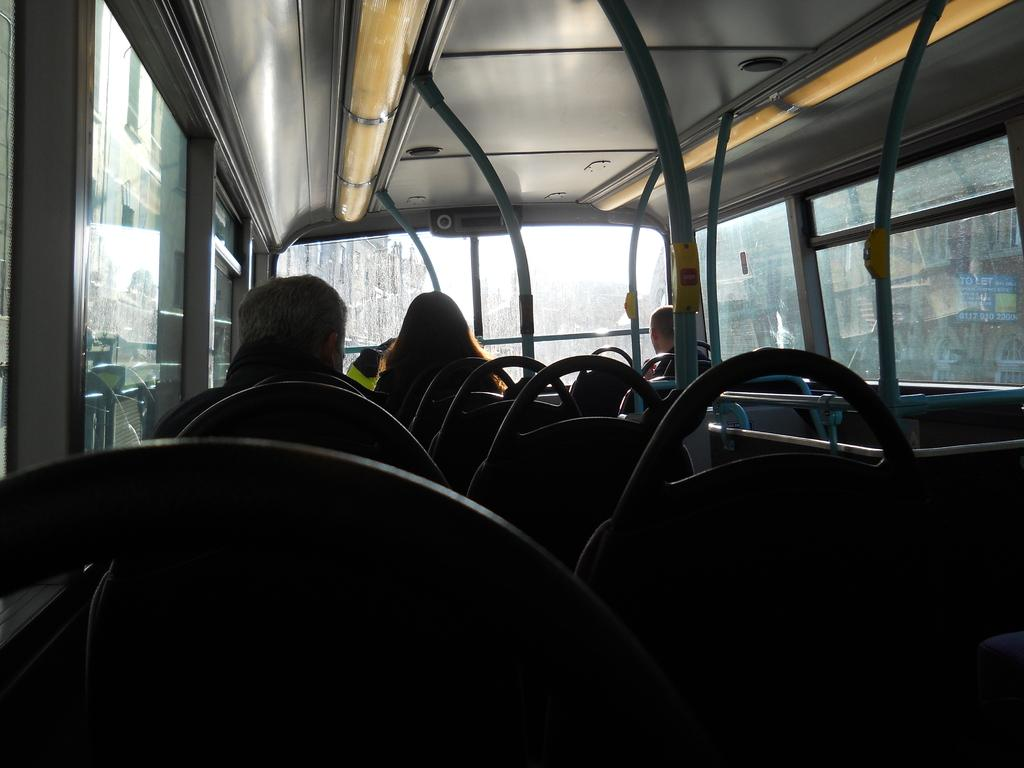What type of environment is depicted in the image? The image shows the interior of a motor vehicle. What can be observed about the occupants of the motor vehicle? There are persons sitting in the seats of the motor vehicle. What type of stew is being served in the motor vehicle? There is no stew present in the image; it depicts the interior of a motor vehicle with persons sitting in the seats. 